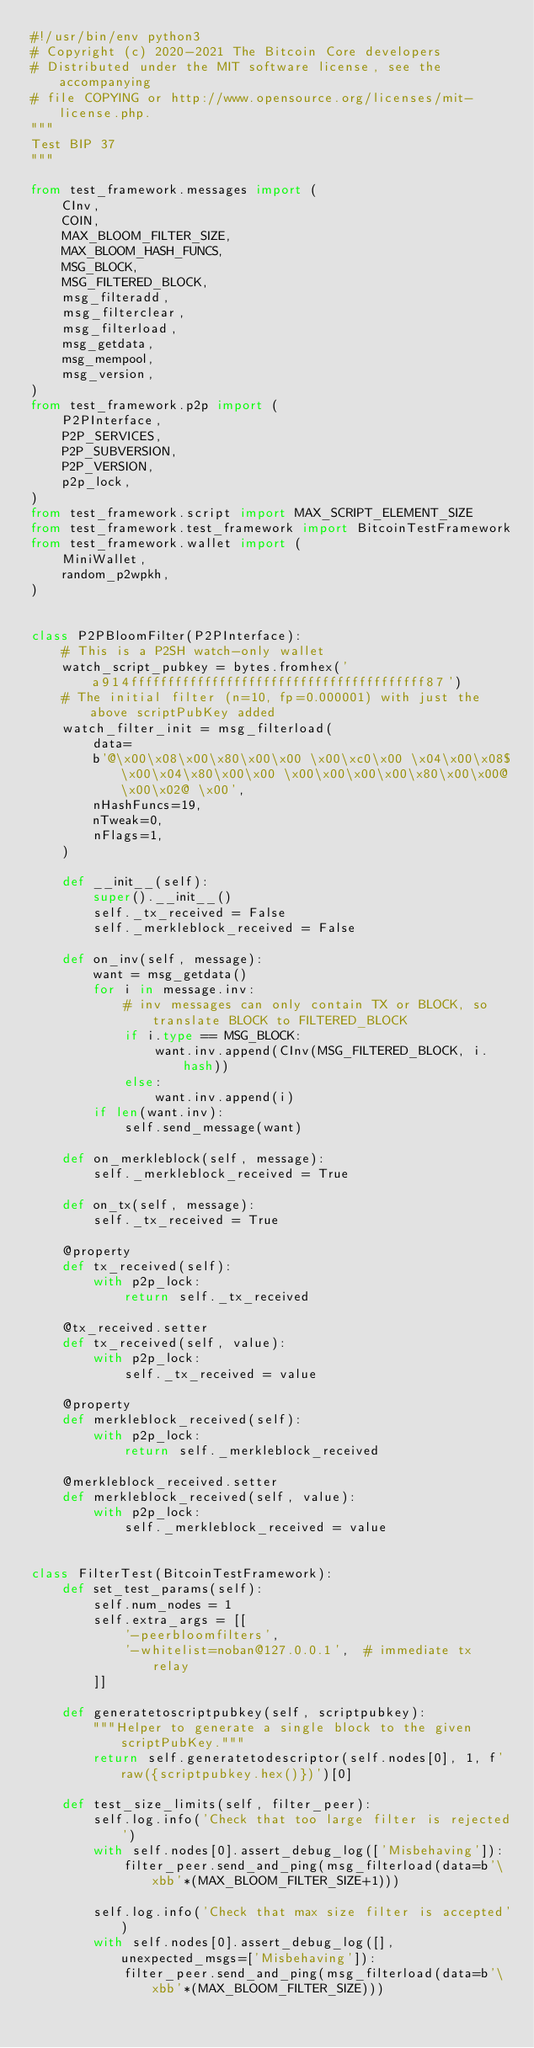<code> <loc_0><loc_0><loc_500><loc_500><_Python_>#!/usr/bin/env python3
# Copyright (c) 2020-2021 The Bitcoin Core developers
# Distributed under the MIT software license, see the accompanying
# file COPYING or http://www.opensource.org/licenses/mit-license.php.
"""
Test BIP 37
"""

from test_framework.messages import (
    CInv,
    COIN,
    MAX_BLOOM_FILTER_SIZE,
    MAX_BLOOM_HASH_FUNCS,
    MSG_BLOCK,
    MSG_FILTERED_BLOCK,
    msg_filteradd,
    msg_filterclear,
    msg_filterload,
    msg_getdata,
    msg_mempool,
    msg_version,
)
from test_framework.p2p import (
    P2PInterface,
    P2P_SERVICES,
    P2P_SUBVERSION,
    P2P_VERSION,
    p2p_lock,
)
from test_framework.script import MAX_SCRIPT_ELEMENT_SIZE
from test_framework.test_framework import BitcoinTestFramework
from test_framework.wallet import (
    MiniWallet,
    random_p2wpkh,
)


class P2PBloomFilter(P2PInterface):
    # This is a P2SH watch-only wallet
    watch_script_pubkey = bytes.fromhex('a914ffffffffffffffffffffffffffffffffffffffff87')
    # The initial filter (n=10, fp=0.000001) with just the above scriptPubKey added
    watch_filter_init = msg_filterload(
        data=
        b'@\x00\x08\x00\x80\x00\x00 \x00\xc0\x00 \x04\x00\x08$\x00\x04\x80\x00\x00 \x00\x00\x00\x00\x80\x00\x00@\x00\x02@ \x00',
        nHashFuncs=19,
        nTweak=0,
        nFlags=1,
    )

    def __init__(self):
        super().__init__()
        self._tx_received = False
        self._merkleblock_received = False

    def on_inv(self, message):
        want = msg_getdata()
        for i in message.inv:
            # inv messages can only contain TX or BLOCK, so translate BLOCK to FILTERED_BLOCK
            if i.type == MSG_BLOCK:
                want.inv.append(CInv(MSG_FILTERED_BLOCK, i.hash))
            else:
                want.inv.append(i)
        if len(want.inv):
            self.send_message(want)

    def on_merkleblock(self, message):
        self._merkleblock_received = True

    def on_tx(self, message):
        self._tx_received = True

    @property
    def tx_received(self):
        with p2p_lock:
            return self._tx_received

    @tx_received.setter
    def tx_received(self, value):
        with p2p_lock:
            self._tx_received = value

    @property
    def merkleblock_received(self):
        with p2p_lock:
            return self._merkleblock_received

    @merkleblock_received.setter
    def merkleblock_received(self, value):
        with p2p_lock:
            self._merkleblock_received = value


class FilterTest(BitcoinTestFramework):
    def set_test_params(self):
        self.num_nodes = 1
        self.extra_args = [[
            '-peerbloomfilters',
            '-whitelist=noban@127.0.0.1',  # immediate tx relay
        ]]

    def generatetoscriptpubkey(self, scriptpubkey):
        """Helper to generate a single block to the given scriptPubKey."""
        return self.generatetodescriptor(self.nodes[0], 1, f'raw({scriptpubkey.hex()})')[0]

    def test_size_limits(self, filter_peer):
        self.log.info('Check that too large filter is rejected')
        with self.nodes[0].assert_debug_log(['Misbehaving']):
            filter_peer.send_and_ping(msg_filterload(data=b'\xbb'*(MAX_BLOOM_FILTER_SIZE+1)))

        self.log.info('Check that max size filter is accepted')
        with self.nodes[0].assert_debug_log([], unexpected_msgs=['Misbehaving']):
            filter_peer.send_and_ping(msg_filterload(data=b'\xbb'*(MAX_BLOOM_FILTER_SIZE)))</code> 